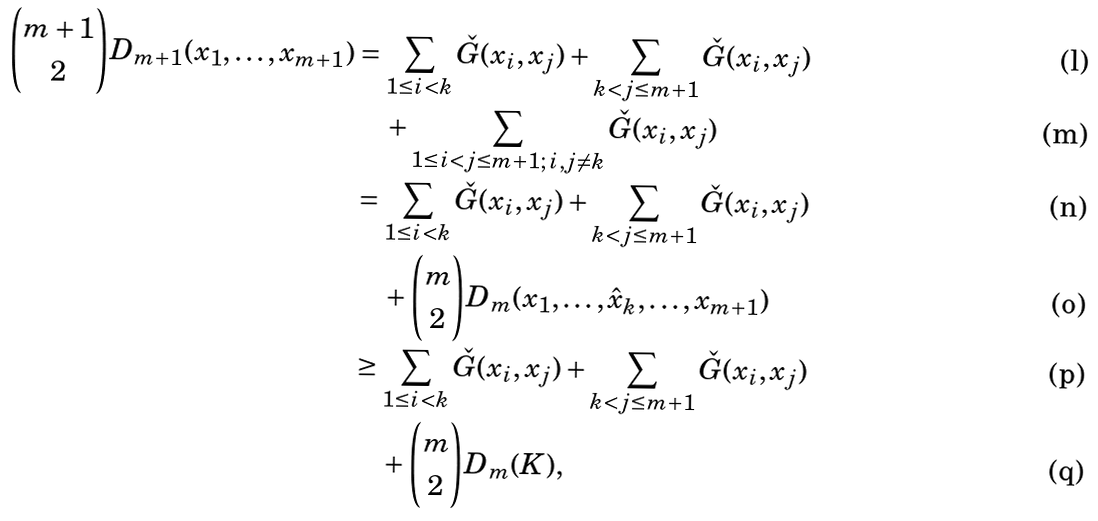<formula> <loc_0><loc_0><loc_500><loc_500>\binom { m + 1 } { 2 } D _ { m + 1 } ( x _ { 1 } , \dots , x _ { m + 1 } ) & = \sum _ { 1 \leq i < k } \check { G } ( x _ { i } , x _ { j } ) + \sum _ { k < j \leq m + 1 } \check { G } ( x _ { i } , x _ { j } ) \\ & \quad + \sum _ { 1 \leq i < j \leq m + 1 ; \, i , j \neq k } \check { G } ( x _ { i } , x _ { j } ) \\ & = \sum _ { 1 \leq i < k } \check { G } ( x _ { i } , x _ { j } ) + \sum _ { k < j \leq m + 1 } \check { G } ( x _ { i } , x _ { j } ) \\ & \quad + \binom { m } { 2 } D _ { m } ( x _ { 1 } , \dots , \hat { x } _ { k } , \dots , x _ { m + 1 } ) \\ & \geq \sum _ { 1 \leq i < k } \check { G } ( x _ { i } , x _ { j } ) + \sum _ { k < j \leq m + 1 } \check { G } ( x _ { i } , x _ { j } ) \\ & \quad + \binom { m } { 2 } D _ { m } ( K ) ,</formula> 